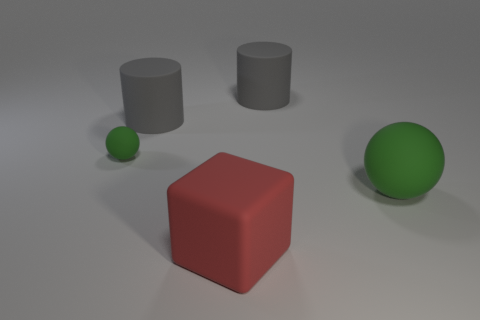Add 3 spheres. How many objects exist? 8 Subtract all spheres. How many objects are left? 3 Add 3 large green cylinders. How many large green cylinders exist? 3 Subtract 0 purple spheres. How many objects are left? 5 Subtract all large red blocks. Subtract all gray objects. How many objects are left? 2 Add 1 small objects. How many small objects are left? 2 